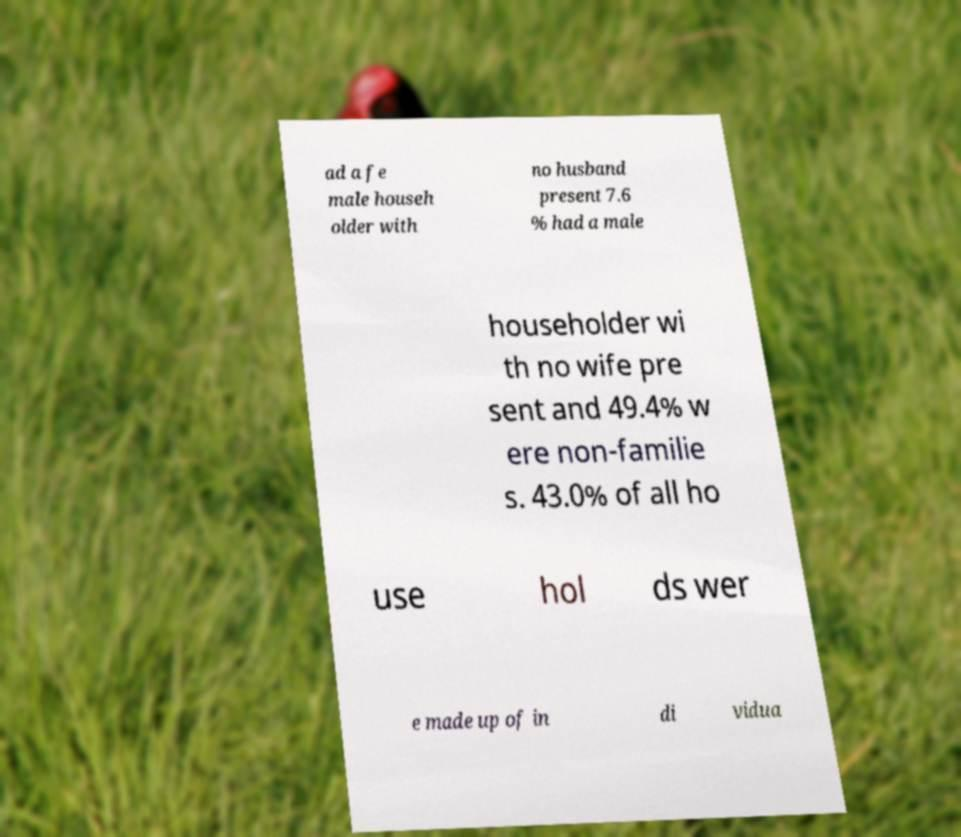There's text embedded in this image that I need extracted. Can you transcribe it verbatim? ad a fe male househ older with no husband present 7.6 % had a male householder wi th no wife pre sent and 49.4% w ere non-familie s. 43.0% of all ho use hol ds wer e made up of in di vidua 